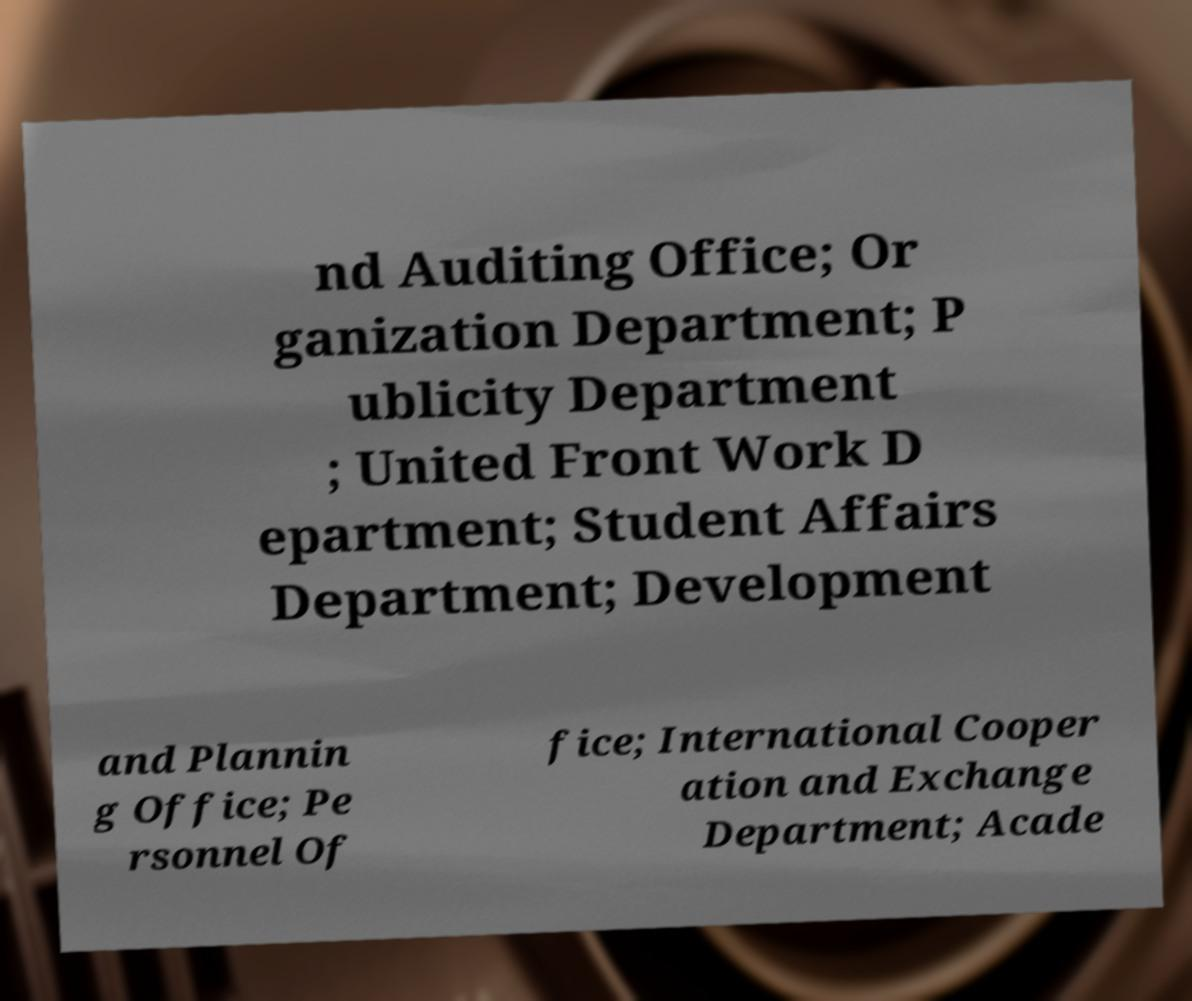Please identify and transcribe the text found in this image. nd Auditing Office; Or ganization Department; P ublicity Department ; United Front Work D epartment; Student Affairs Department; Development and Plannin g Office; Pe rsonnel Of fice; International Cooper ation and Exchange Department; Acade 